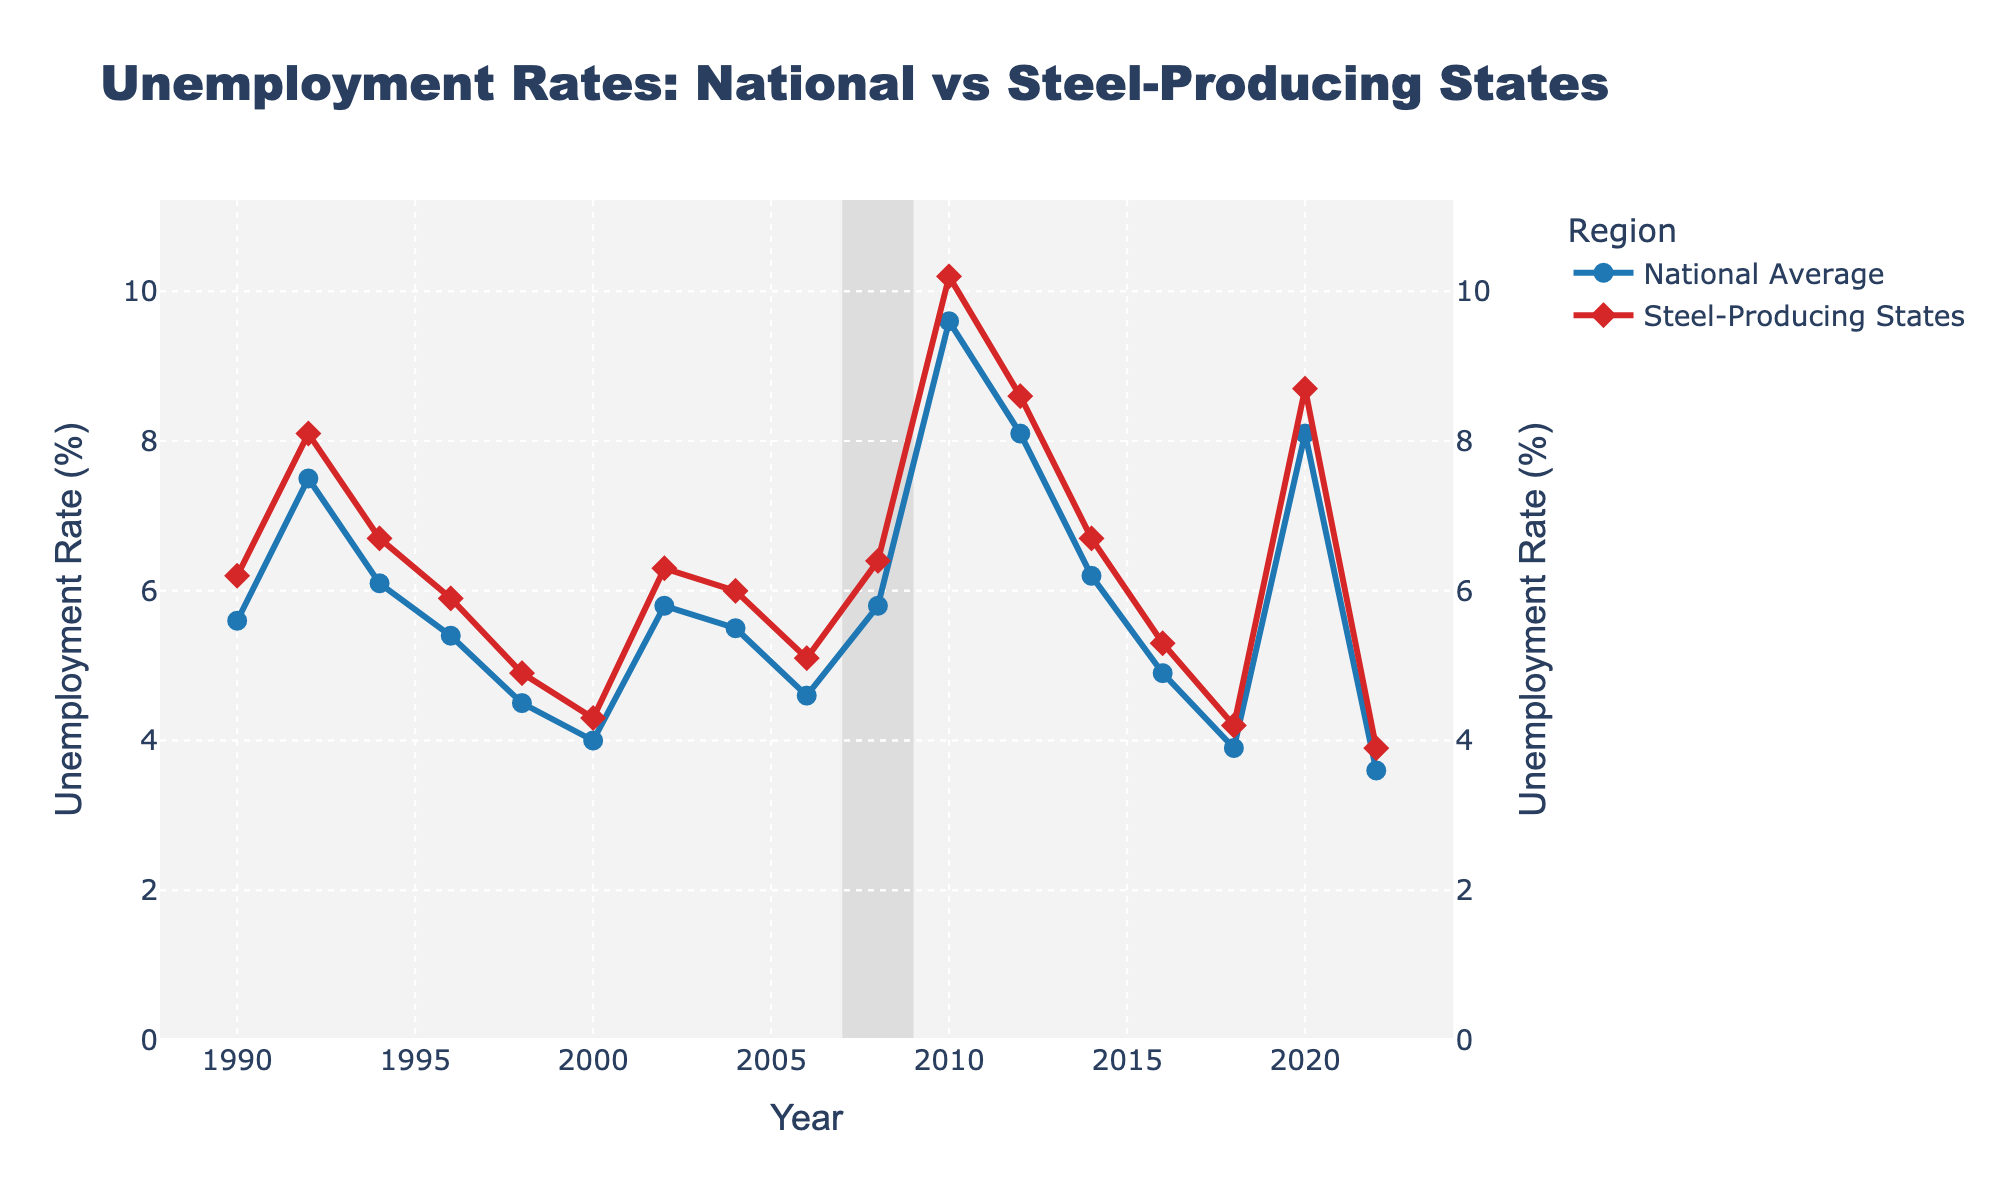What's the highest unemployment rate in steel-producing states? Find the peak point in the red line representing the unemployment rate in steel-producing states. The highest rate is at 2010 with 10.2%.
Answer: 10.2% When did the national average unemployment rate peak? Look for the highest point along the blue line marking the national average. The peak is at 2010 with 9.6%.
Answer: 2010 During which year did the unemployment rate in steel-producing states drop below the national average? Look for the intersection point where the red line (steel-producing states) crosses below the blue line (national average). This occurs in 2022 when the steel states unemployment rate is 3.9% and the national average is 3.6%.
Answer: 2022 What is the difference in unemployment rates between steel-producing states and the national average in 2008? Subtract the national average (blue line) from the steel-producing states rate (red line) for the year 2008. The difference is 6.4% - 5.8% = 0.6%.
Answer: 0.6% Which period showed the most significant decline in the unemployment rate for steel-producing states? Identify the steepest descent in the red line for steel-producing states. The period from 2010 to 2018 shows a significant decline from 10.2% to 4.2%.
Answer: 2010-2018 Which recession period had the greatest impact on national unemployment rates? Examine the shaded recession periods and observe the changes in the blue line. The 2007-2009 recession shows the most significant impact with an increase from about 4.6% to 9.6%.
Answer: 2007-2009 Between 2010 and 2014, how did the unemployment rate in steel-producing states change compared to the national average? Calculate the change for both lines: steel-producing states fell from 10.2% to 6.7%, a change of -3.5%; the national average fell from 9.6% to 6.2%, a change of -3.4%.
Answer: Steel-producing states: -3.5%, National average: -3.4% What year marked the smallest difference between the unemployment rates of steel-producing states and the national average? Subtract the national rate (blue line) from the steel-producing rate (red line) for each year and find the minimum difference. In 2016, the difference is 5.3% - 4.9% = 0.4%.
Answer: 2016 